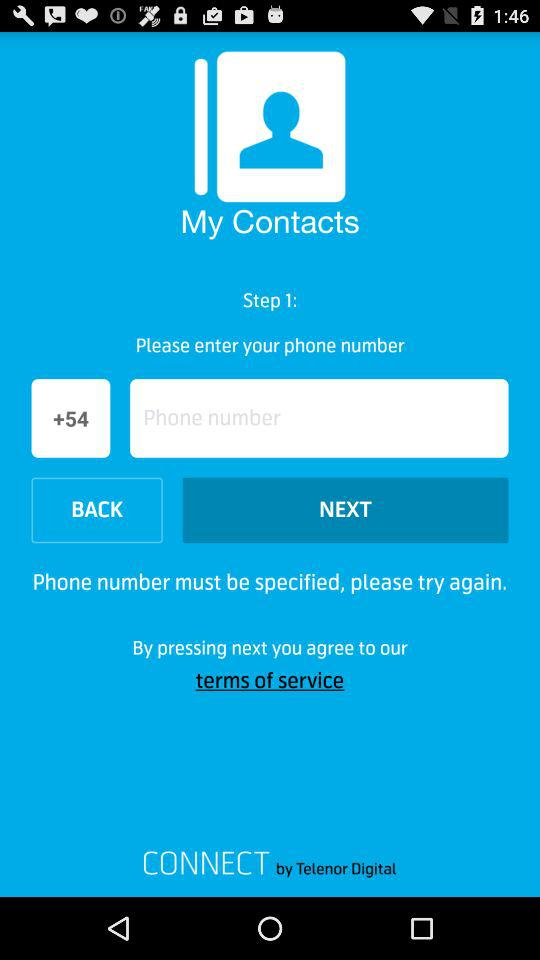What is the country code? The country code is +54. 